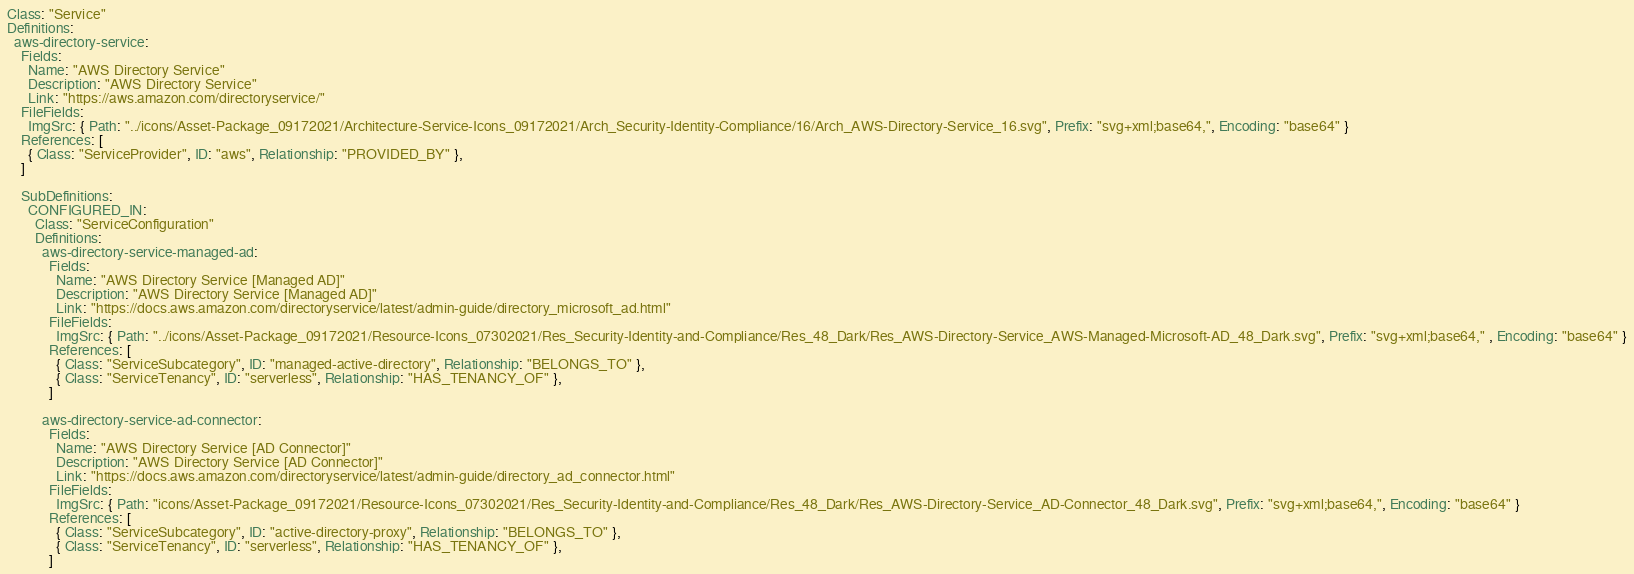Convert code to text. <code><loc_0><loc_0><loc_500><loc_500><_YAML_>Class: "Service"
Definitions:
  aws-directory-service:
    Fields:
      Name: "AWS Directory Service"
      Description: "AWS Directory Service"
      Link: "https://aws.amazon.com/directoryservice/"
    FileFields:
      ImgSrc: { Path: "../icons/Asset-Package_09172021/Architecture-Service-Icons_09172021/Arch_Security-Identity-Compliance/16/Arch_AWS-Directory-Service_16.svg", Prefix: "svg+xml;base64,", Encoding: "base64" }
    References: [
      { Class: "ServiceProvider", ID: "aws", Relationship: "PROVIDED_BY" },
    ]

    SubDefinitions:
      CONFIGURED_IN:
        Class: "ServiceConfiguration"
        Definitions:
          aws-directory-service-managed-ad:
            Fields:
              Name: "AWS Directory Service [Managed AD]"
              Description: "AWS Directory Service [Managed AD]"
              Link: "https://docs.aws.amazon.com/directoryservice/latest/admin-guide/directory_microsoft_ad.html"
            FileFields:
              ImgSrc: { Path: "../icons/Asset-Package_09172021/Resource-Icons_07302021/Res_Security-Identity-and-Compliance/Res_48_Dark/Res_AWS-Directory-Service_AWS-Managed-Microsoft-AD_48_Dark.svg", Prefix: "svg+xml;base64," , Encoding: "base64" }
            References: [
              { Class: "ServiceSubcategory", ID: "managed-active-directory", Relationship: "BELONGS_TO" },
              { Class: "ServiceTenancy", ID: "serverless", Relationship: "HAS_TENANCY_OF" },
            ]

          aws-directory-service-ad-connector:
            Fields:
              Name: "AWS Directory Service [AD Connector]"
              Description: "AWS Directory Service [AD Connector]"
              Link: "https://docs.aws.amazon.com/directoryservice/latest/admin-guide/directory_ad_connector.html"
            FileFields:
              ImgSrc: { Path: "icons/Asset-Package_09172021/Resource-Icons_07302021/Res_Security-Identity-and-Compliance/Res_48_Dark/Res_AWS-Directory-Service_AD-Connector_48_Dark.svg", Prefix: "svg+xml;base64,", Encoding: "base64" }
            References: [
              { Class: "ServiceSubcategory", ID: "active-directory-proxy", Relationship: "BELONGS_TO" },
              { Class: "ServiceTenancy", ID: "serverless", Relationship: "HAS_TENANCY_OF" },
            ]

</code> 